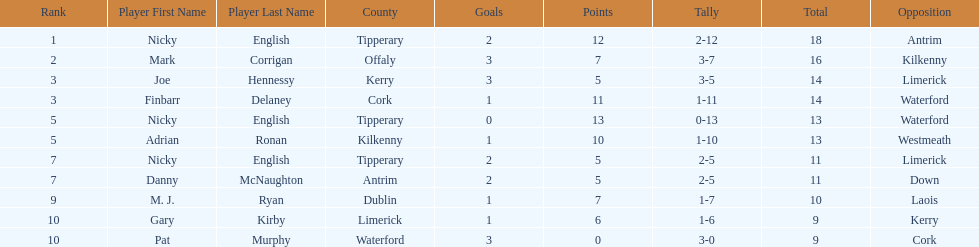How many people are on the list? 9. 